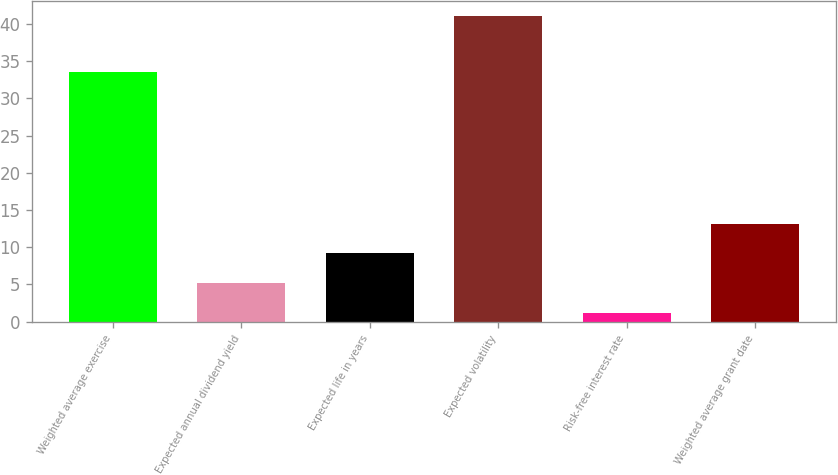Convert chart to OTSL. <chart><loc_0><loc_0><loc_500><loc_500><bar_chart><fcel>Weighted average exercise<fcel>Expected annual dividend yield<fcel>Expected life in years<fcel>Expected volatility<fcel>Risk-free interest rate<fcel>Weighted average grant date<nl><fcel>33.52<fcel>5.18<fcel>9.16<fcel>41<fcel>1.2<fcel>13.14<nl></chart> 